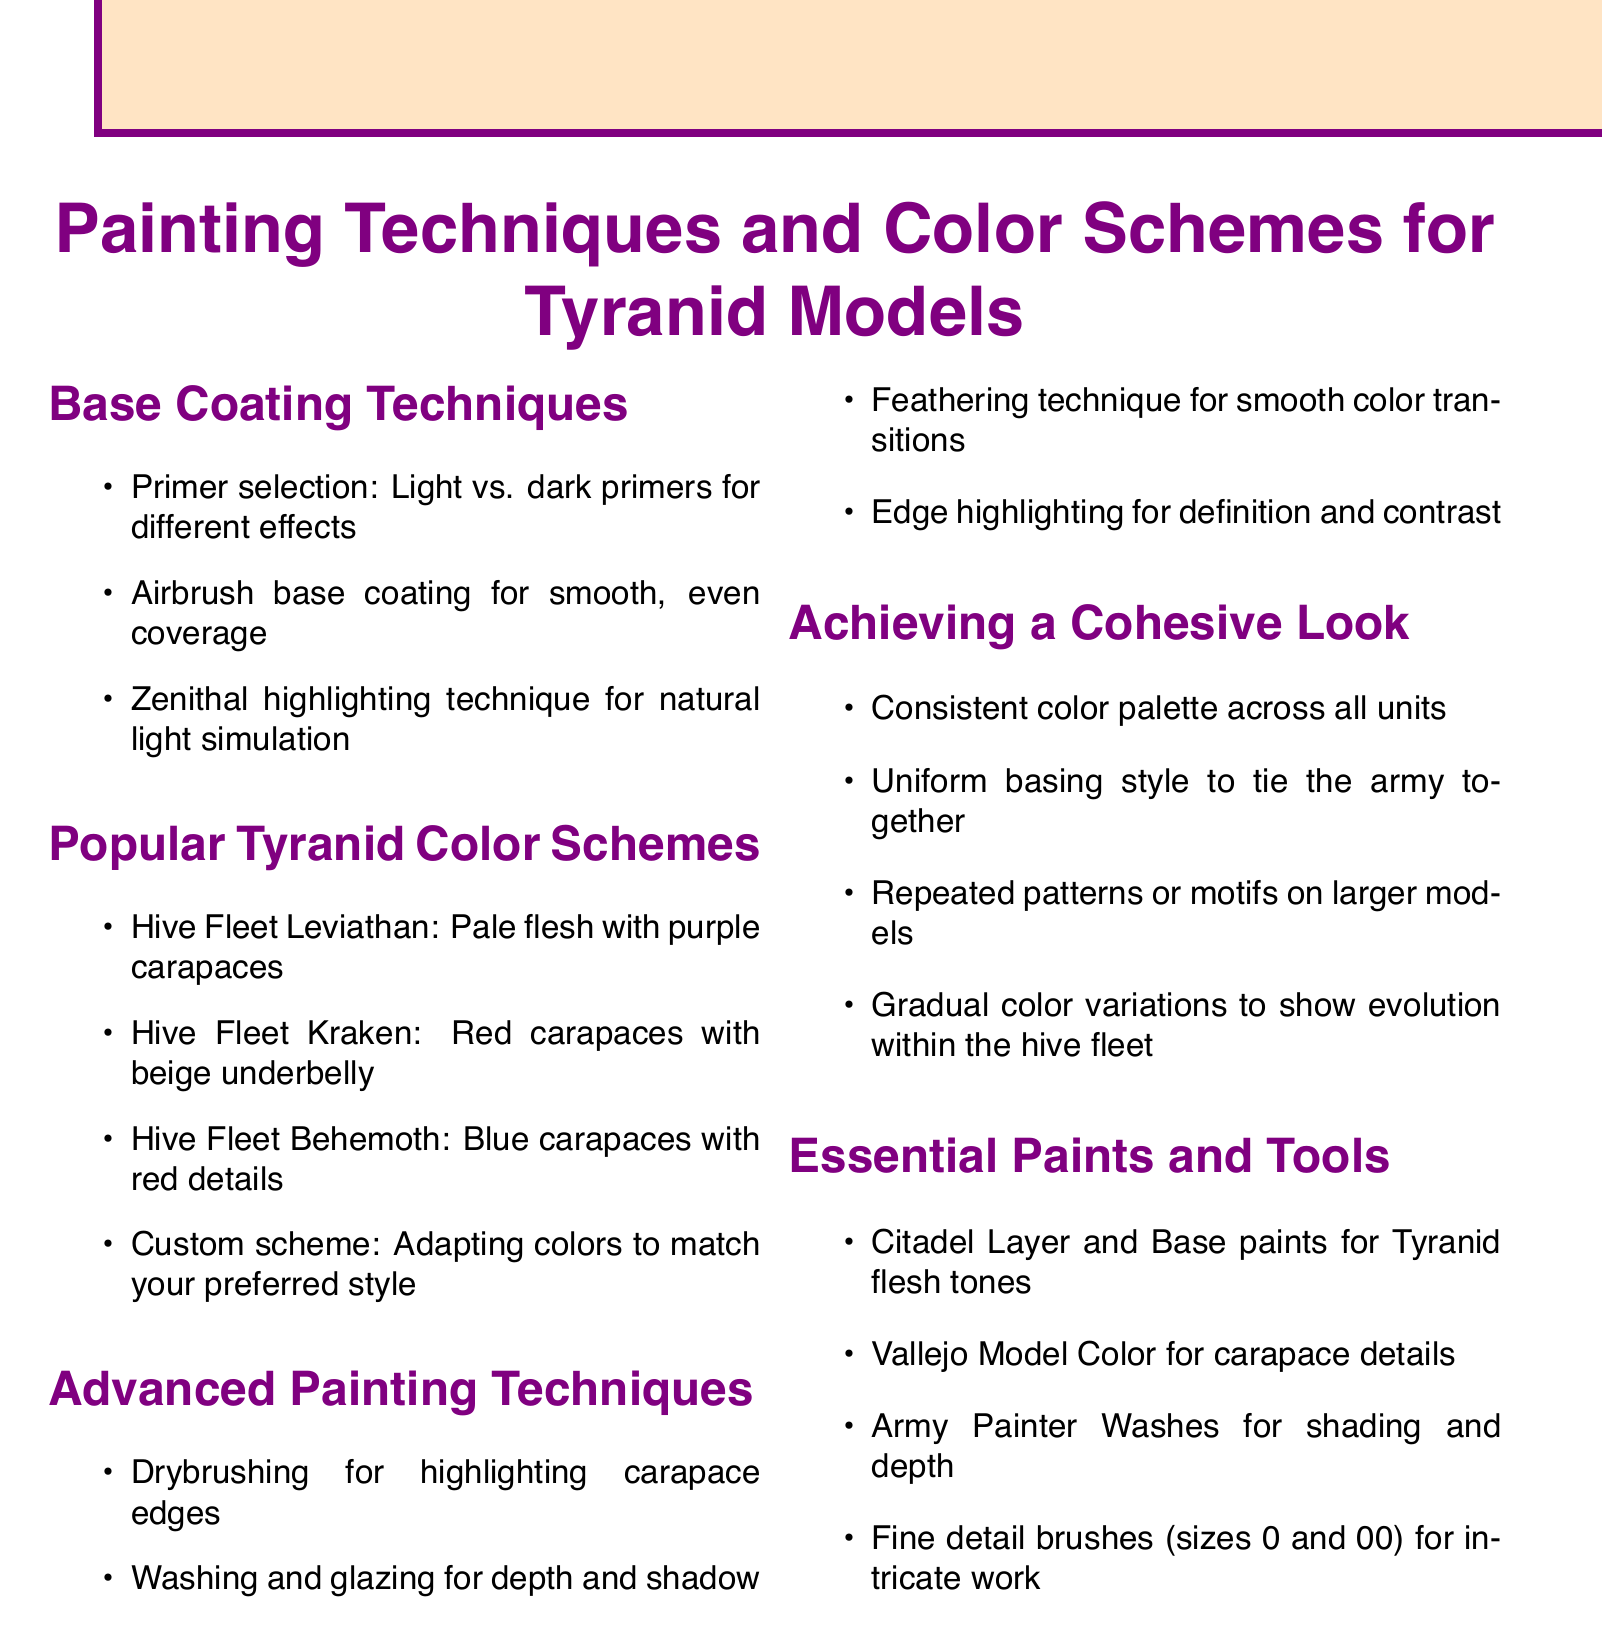What is a recommended primer selection for base coating? The document lists the importance of choosing between light and dark primers for different effects in base coating.
Answer: Light vs. dark primers Name a popular color scheme for Tyranids. The document provides several examples of popular color schemes, such as Hive Fleet Leviathan.
Answer: Hive Fleet Leviathan What technique is suggested for highlighting carapace edges? The document mentions drybrushing as a technique for this purpose under advanced painting techniques.
Answer: Drybrushing What should be consistent to achieve a cohesive look? The document emphasizes the need for a consistent color palette across all units to maintain a cohesive look.
Answer: Consistent color palette Which paint brand is mentioned for Tyranid flesh tones? The document specifies Citadel Layer and Base paints as essential for Tyranid flesh tones.
Answer: Citadel Layer and Base paints What is one way to show evolution within the hive fleet? The document suggests using gradual color variations to represent this evolution within the hive fleet.
Answer: Gradual color variations What type of brushes are recommended for intricate work? The document recommends fine detail brushes, specifically sizes 0 and 00, for this purpose.
Answer: Sizes 0 and 00 What is the purpose of using the feathering technique? This technique is mentioned in the document for achieving smooth color transitions, representing its purpose.
Answer: Smooth color transitions Which color is associated with Hive Fleet Behemoth? The document indicates that the color scheme for Hive Fleet Behemoth includes blue carapaces with red details.
Answer: Blue carapaces with red details 